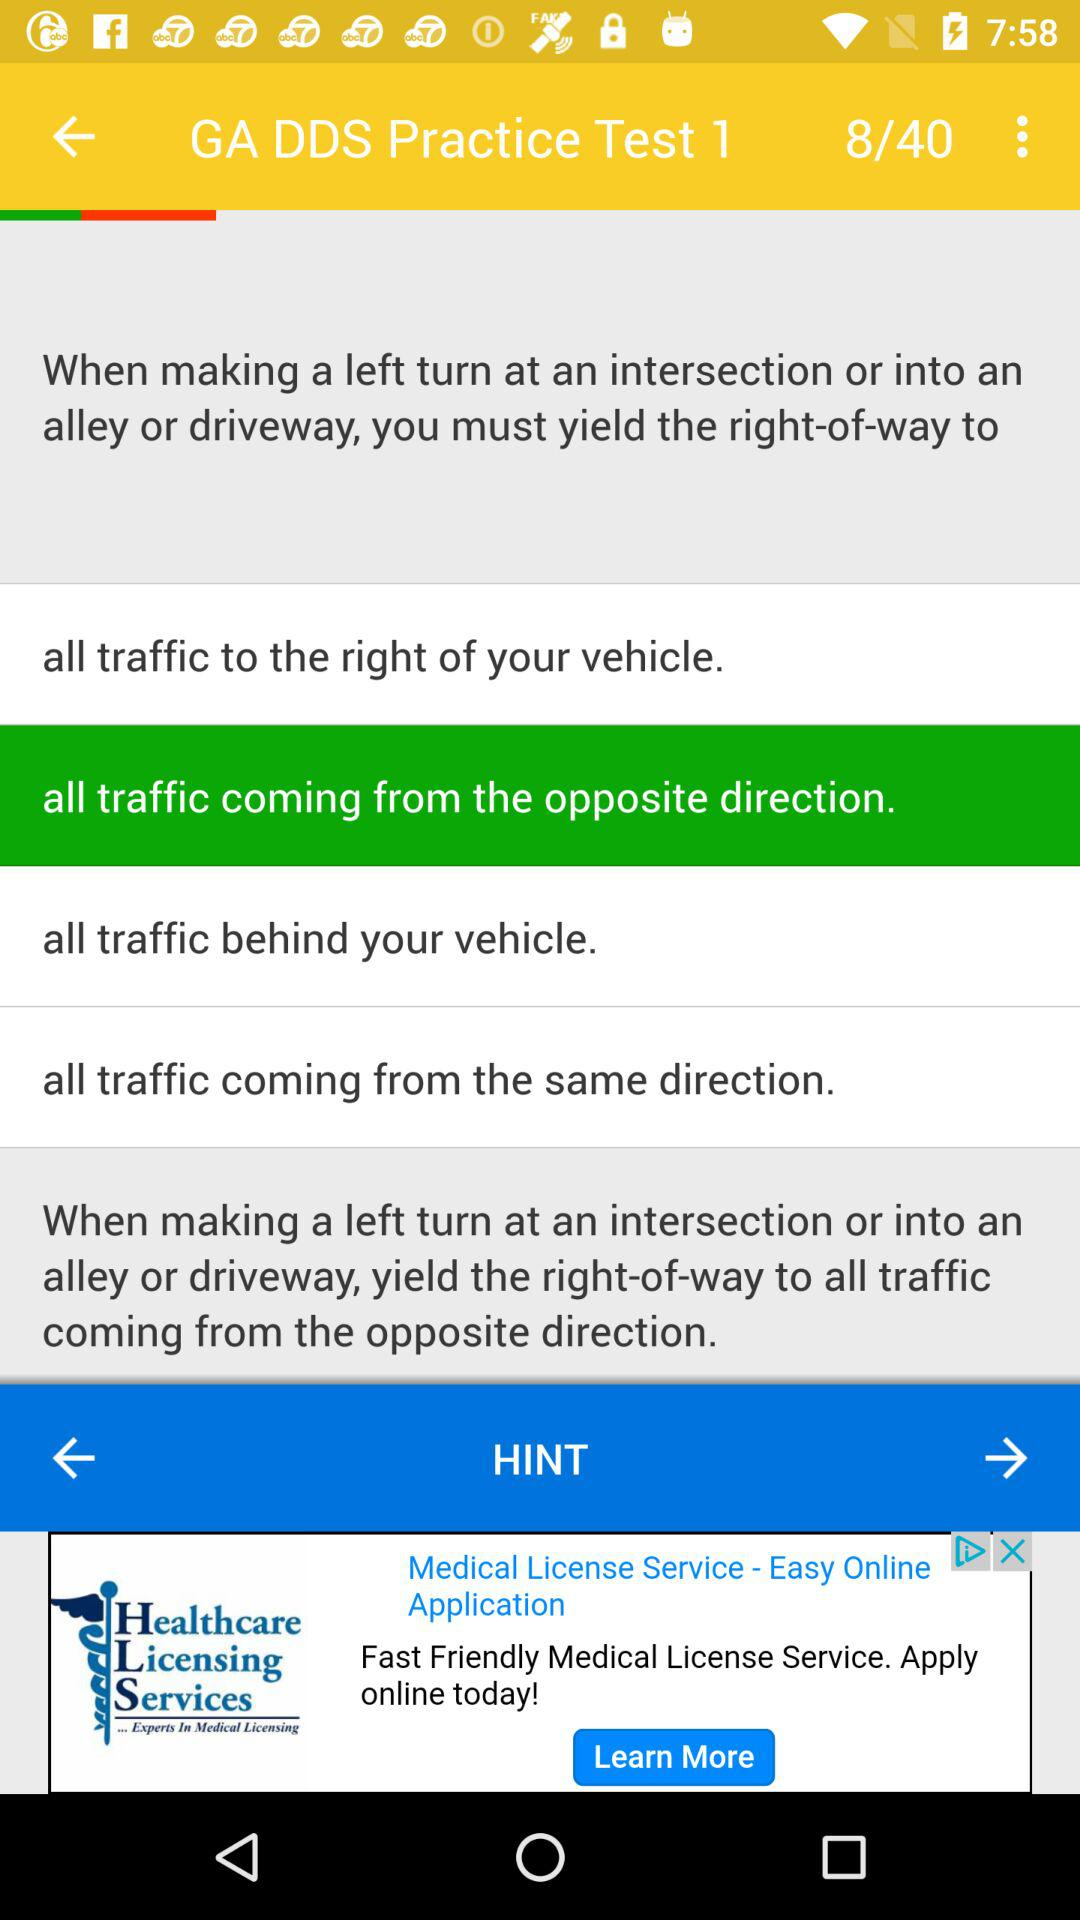What is the total number of questions? The total number of questions is 40. 